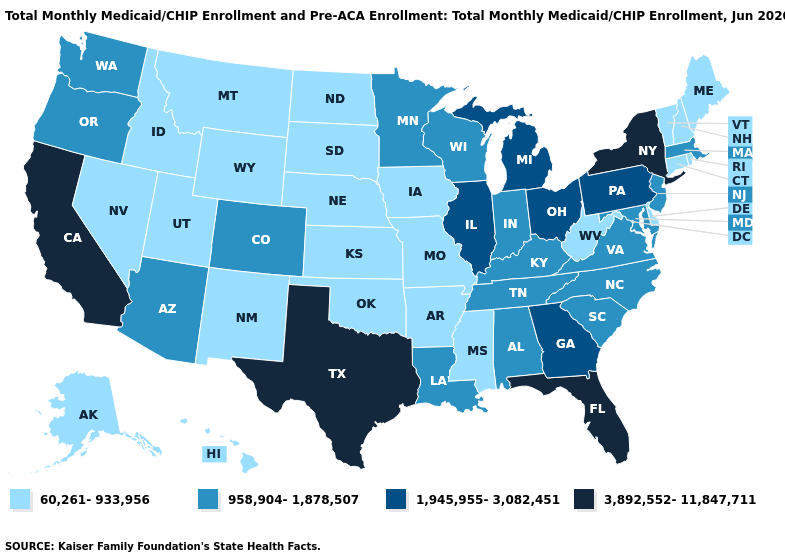What is the lowest value in the South?
Short answer required. 60,261-933,956. Does New Hampshire have the same value as Oklahoma?
Answer briefly. Yes. Which states hav the highest value in the West?
Quick response, please. California. What is the value of Washington?
Concise answer only. 958,904-1,878,507. Among the states that border Kansas , does Nebraska have the highest value?
Give a very brief answer. No. Does Mississippi have the lowest value in the South?
Give a very brief answer. Yes. What is the highest value in the South ?
Be succinct. 3,892,552-11,847,711. Name the states that have a value in the range 958,904-1,878,507?
Write a very short answer. Alabama, Arizona, Colorado, Indiana, Kentucky, Louisiana, Maryland, Massachusetts, Minnesota, New Jersey, North Carolina, Oregon, South Carolina, Tennessee, Virginia, Washington, Wisconsin. Does Pennsylvania have the lowest value in the USA?
Keep it brief. No. Which states have the highest value in the USA?
Quick response, please. California, Florida, New York, Texas. Does the first symbol in the legend represent the smallest category?
Be succinct. Yes. Among the states that border South Dakota , does Minnesota have the highest value?
Answer briefly. Yes. What is the value of Kentucky?
Short answer required. 958,904-1,878,507. Name the states that have a value in the range 3,892,552-11,847,711?
Answer briefly. California, Florida, New York, Texas. Among the states that border New Mexico , which have the highest value?
Be succinct. Texas. 